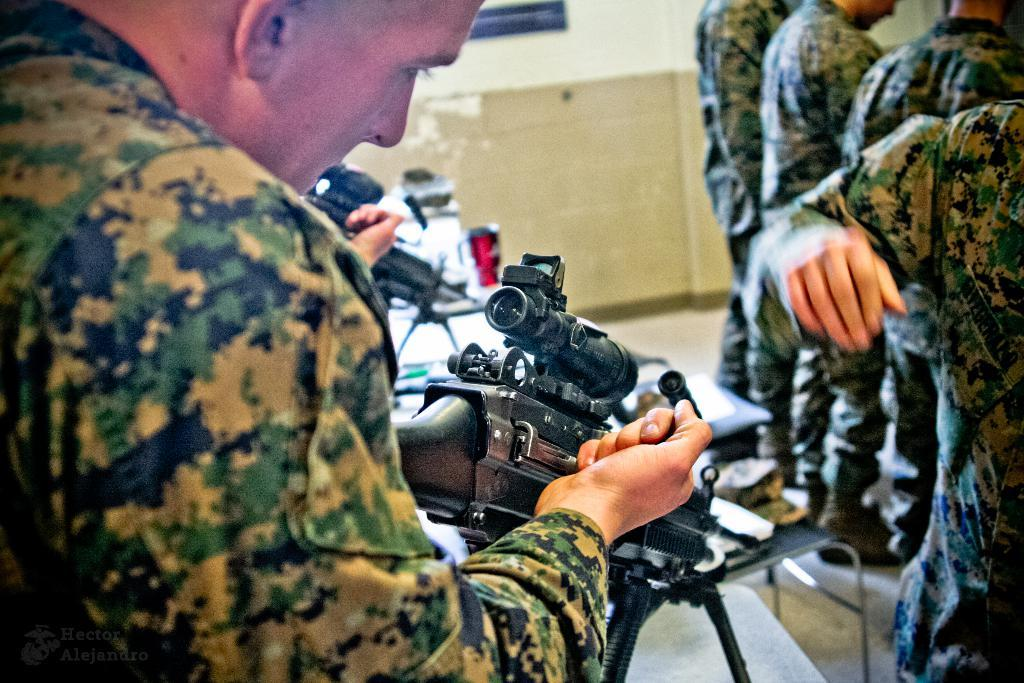What is happening in the image? There are people standing in the image, and a man in the front is looking at a gun. What can be seen in the background of the image? There is a wall in the background of the image. Are there any other guns visible in the image? Yes, there is another gun visible in the image. How does the beetle contribute to the trade depicted in the image? There is no beetle present in the image, and therefore no trade involving a beetle can be observed. 